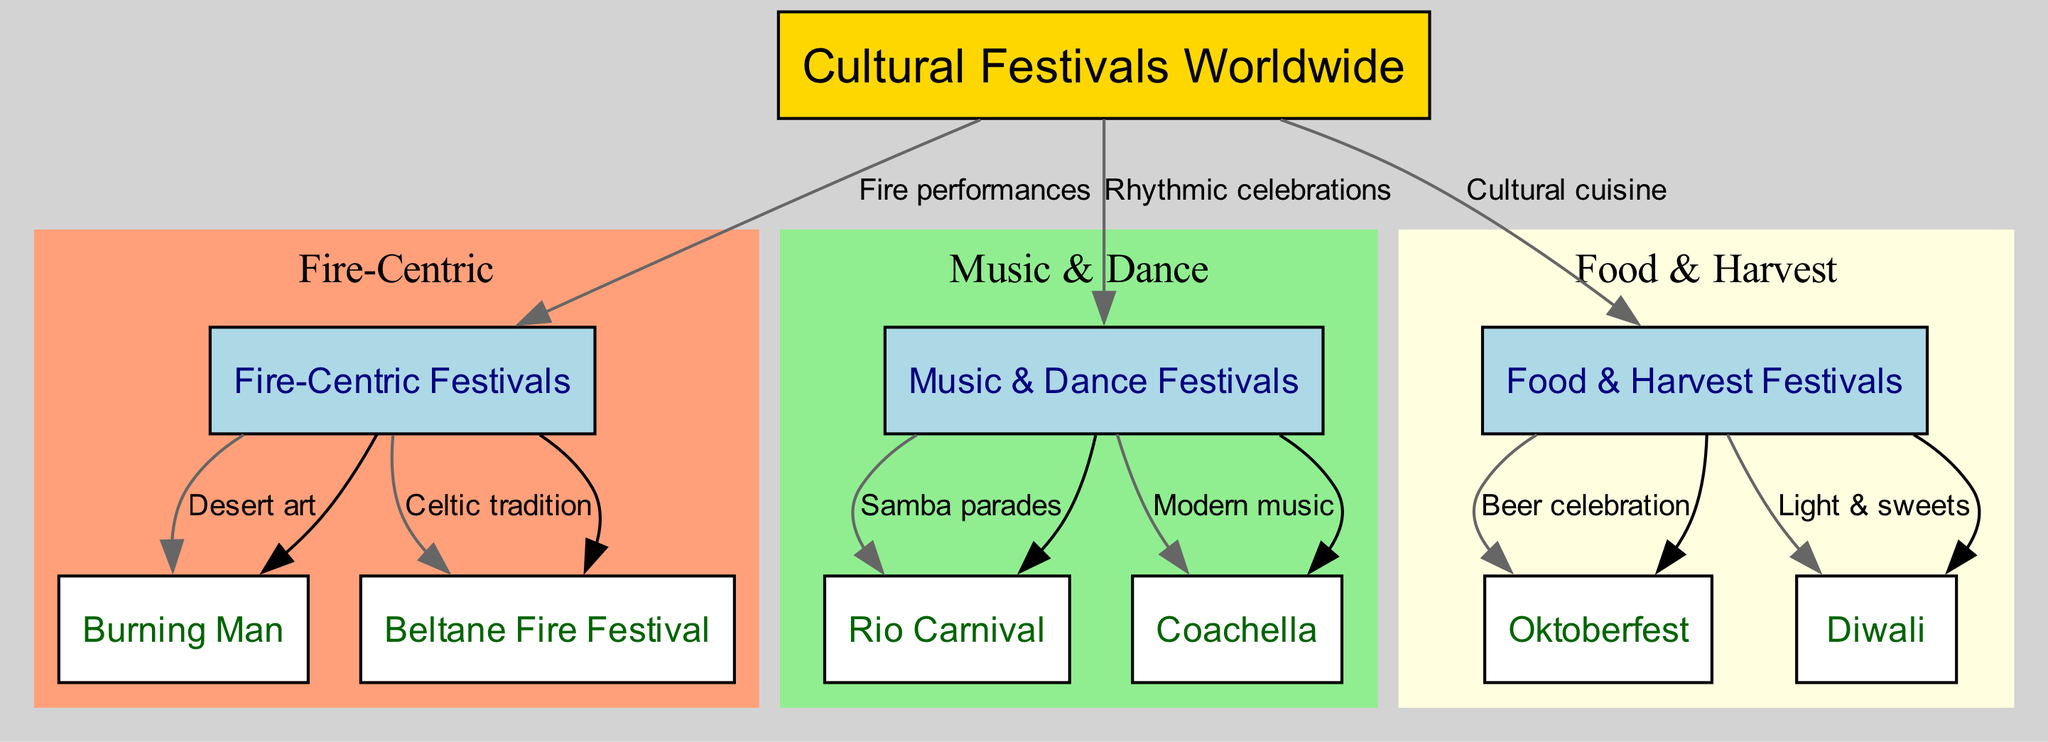How many groups are there in the diagram? The diagram contains three groups labeled as Fire-Centric Festivals, Music & Dance Festivals, and Food & Harvest Festivals. This can be counted directly from the group nodes under the root node.
Answer: 3 Which festival is connected to the Fire-Centric group? The festivals connected to the Fire-Centric group include Burning Man and Beltane Fire Festival as shown by the edges leading from the group node to these festival nodes.
Answer: Burning Man, Beltane Fire Festival What type of performance is associated with the Music & Dance Festivals group? The edge from the root node to the Music & Dance Festivals group is labeled "Rhythmic celebrations," indicating the primary characteristic of this group.
Answer: Rhythmic celebrations How many festivals are grouped under Food & Harvest Festivals? The Food & Harvest Festivals group contains two festivals: Oktoberfest and Diwali, which can be identified by counting the edges from the group to the festival nodes.
Answer: 2 Which festival features Samba parades? The diagram shows an edge connecting the Music & Dance Festivals group to the Rio Carnival, indicating that this festival features Samba parades as part of its celebration.
Answer: Rio Carnival What is the label for the edge connecting the root node to Food & Harvest Festivals? The label on the edge connecting the root node to the Food & Harvest Festivals group specifies "Cultural cuisine," which signifies the core characteristic of this group.
Answer: Cultural cuisine Which subgraph has the label 'Fire-Centric'? The subgraph containing the festivals Burning Man and Beltane Fire Festival is labeled 'Fire-Centric,' as indicated in the clustering representation within the diagram.
Answer: Fire-Centric Which festival is associated with the light and sweets characteristic? The festival connected to the Food & Harvest group, which represents light and sweets, is Diwali, shown by the edge leading from the group node to this festival node.
Answer: Diwali What are the characteristics that define the Fire Centric Festivals group? The Fire-Centric Festivals group is characterized by "Fire performances," which is indicated on the edge leading from the root to this group, and is further represented by the specific festivals.
Answer: Fire performances 